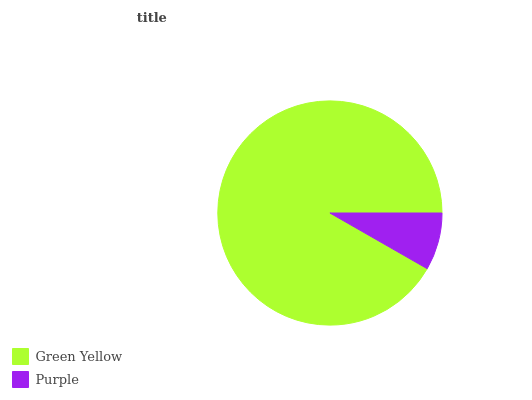Is Purple the minimum?
Answer yes or no. Yes. Is Green Yellow the maximum?
Answer yes or no. Yes. Is Purple the maximum?
Answer yes or no. No. Is Green Yellow greater than Purple?
Answer yes or no. Yes. Is Purple less than Green Yellow?
Answer yes or no. Yes. Is Purple greater than Green Yellow?
Answer yes or no. No. Is Green Yellow less than Purple?
Answer yes or no. No. Is Green Yellow the high median?
Answer yes or no. Yes. Is Purple the low median?
Answer yes or no. Yes. Is Purple the high median?
Answer yes or no. No. Is Green Yellow the low median?
Answer yes or no. No. 